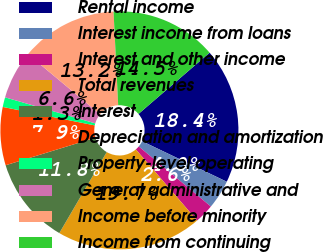Convert chart to OTSL. <chart><loc_0><loc_0><loc_500><loc_500><pie_chart><fcel>Rental income<fcel>Interest income from loans<fcel>Interest and other income<fcel>Total revenues<fcel>Interest<fcel>Depreciation and amortization<fcel>Property-level operating<fcel>General administrative and<fcel>Income before minority<fcel>Income from continuing<nl><fcel>18.42%<fcel>3.95%<fcel>2.63%<fcel>19.74%<fcel>11.84%<fcel>7.89%<fcel>1.32%<fcel>6.58%<fcel>13.16%<fcel>14.47%<nl></chart> 